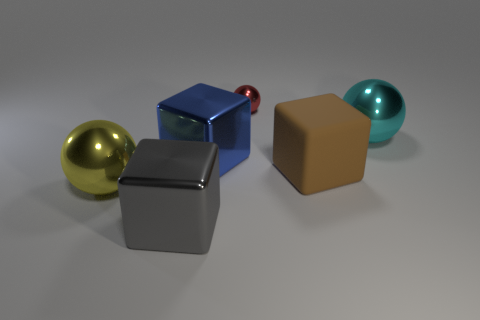Is there any other thing of the same color as the rubber thing?
Offer a terse response. No. There is a block to the right of the large blue metallic block; what is its size?
Offer a terse response. Large. Is the number of balls greater than the number of big red cubes?
Provide a succinct answer. Yes. What material is the gray object?
Provide a short and direct response. Metal. How many other things are the same material as the brown object?
Provide a short and direct response. 0. How many objects are there?
Provide a short and direct response. 6. There is a blue object that is the same shape as the gray thing; what is its material?
Keep it short and to the point. Metal. Are the large thing right of the brown cube and the large brown block made of the same material?
Your answer should be very brief. No. Is the number of cubes that are in front of the matte block greater than the number of small red shiny balls that are left of the yellow shiny ball?
Your response must be concise. Yes. The brown matte cube is what size?
Provide a short and direct response. Large. 